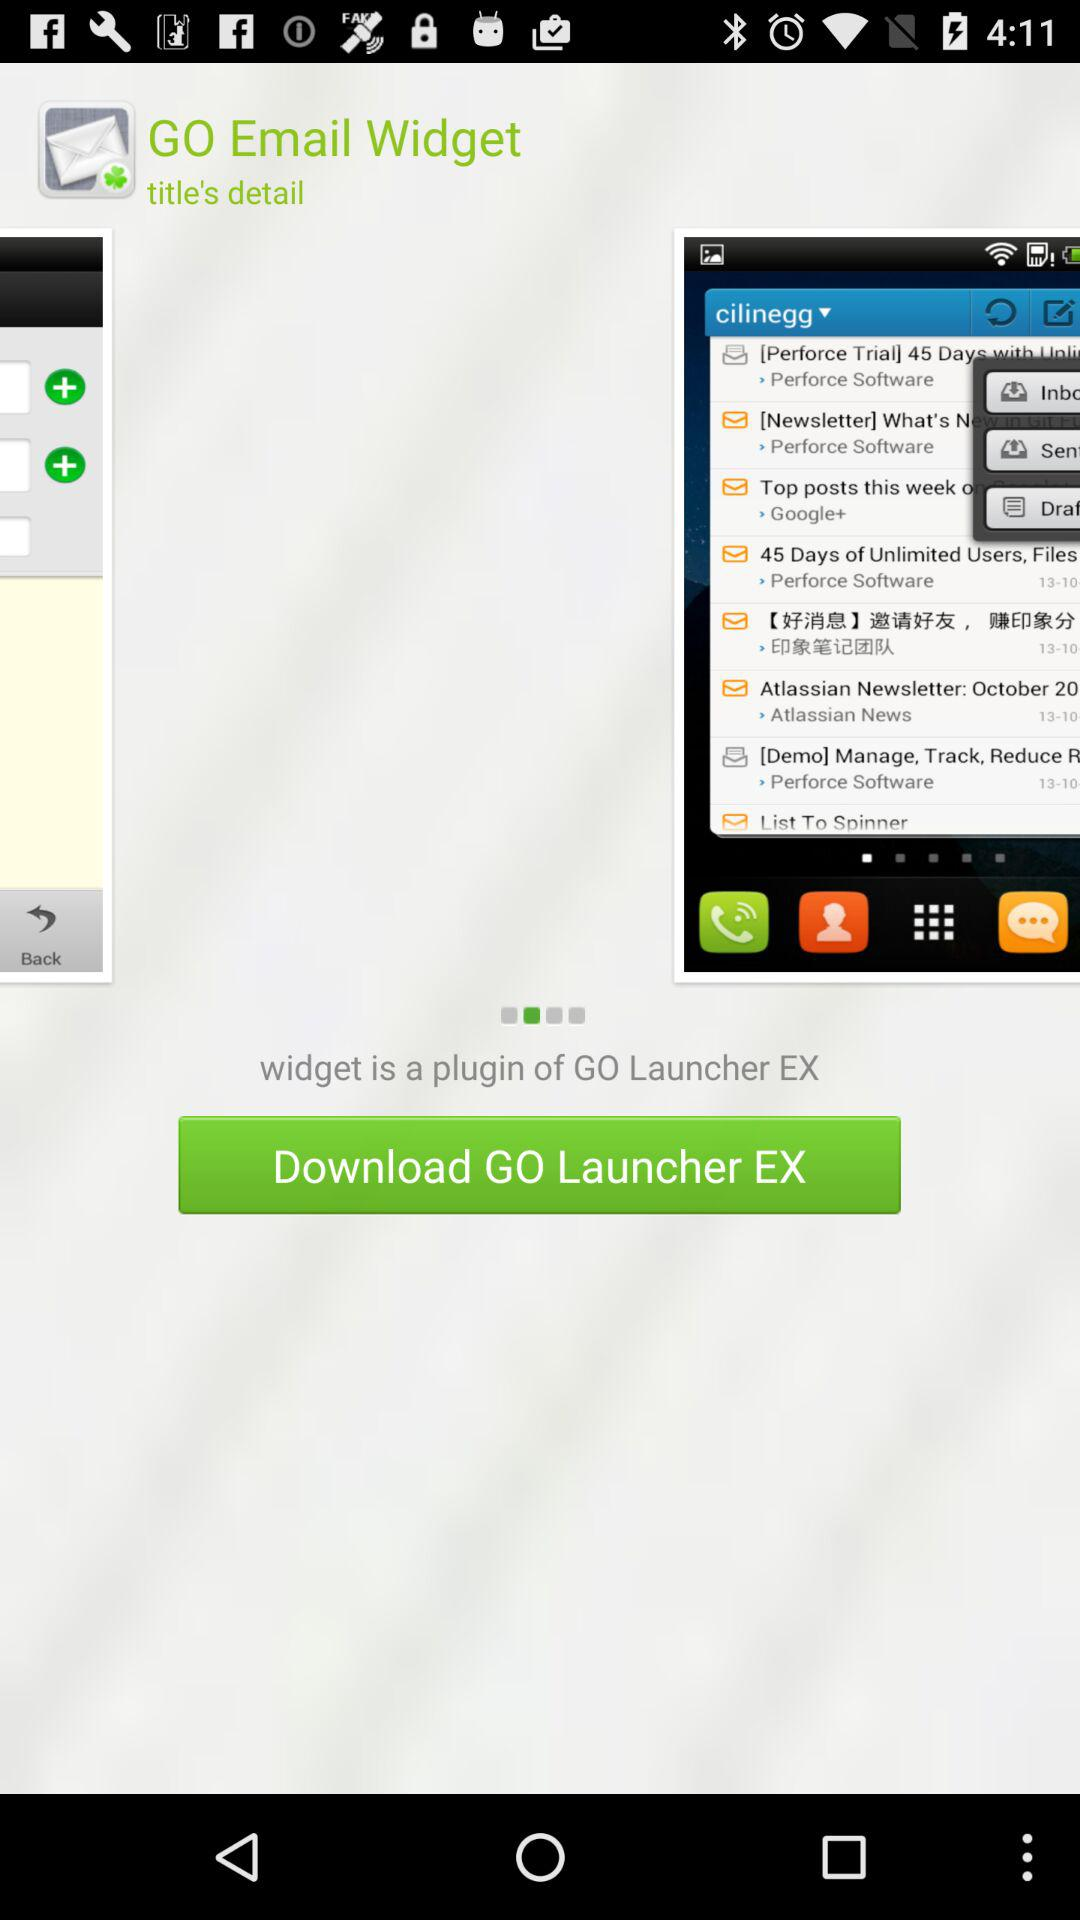What is the application name? The application names are "GO Email Widget" and "GO Launcher EX". 